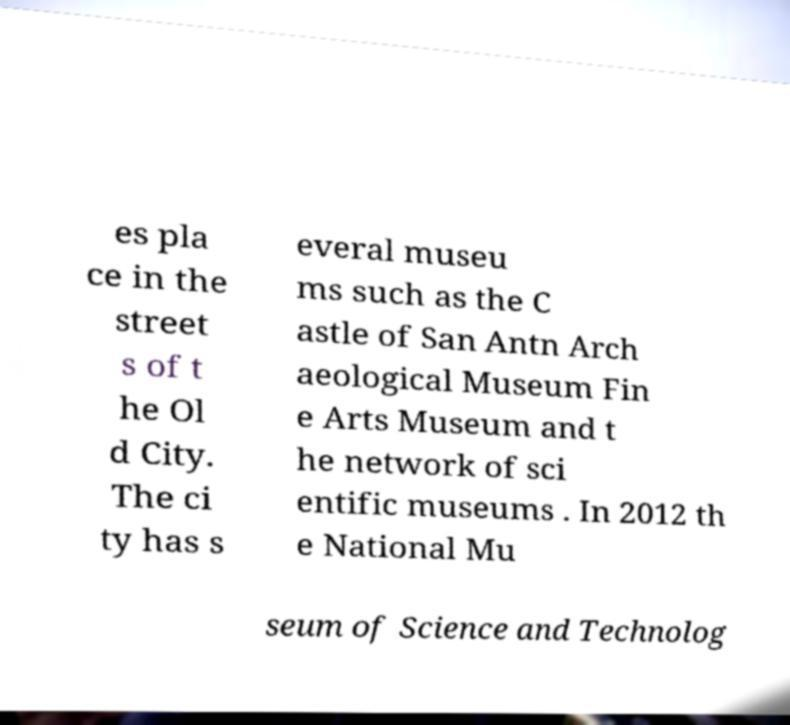Could you assist in decoding the text presented in this image and type it out clearly? es pla ce in the street s of t he Ol d City. The ci ty has s everal museu ms such as the C astle of San Antn Arch aeological Museum Fin e Arts Museum and t he network of sci entific museums . In 2012 th e National Mu seum of Science and Technolog 